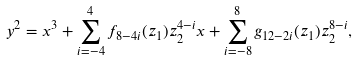Convert formula to latex. <formula><loc_0><loc_0><loc_500><loc_500>y ^ { 2 } = x ^ { 3 } + \sum _ { i = - 4 } ^ { 4 } f _ { 8 - 4 i } ( z _ { 1 } ) z _ { 2 } ^ { 4 - i } x + \sum _ { i = - 8 } ^ { 8 } g _ { 1 2 - 2 i } ( z _ { 1 } ) z _ { 2 } ^ { 8 - i } ,</formula> 